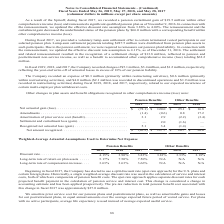From Conagra Brands's financial document, How much were the charges of the year-end write-off of actuarial losses during fiscal 2017, 2018, and 2019, respectively? The document contains multiple relevant values: $1.2 million, $3.4 million, $5.1 million. From the document: "017, the Company recorded charges of $5.1 million, $3.4 million, and $1.2 million, respectively, ecorded charges of $5.1 million, $3.4 million, and $1..." Also, What is the breakdown of $4.0 million expense during fiscal 2017 that was related to expected incurrence of certain multi-employer plan withdrawal costs? $2.1 million was recorded in discontinued operations and $1.9 million was recorded in restructuring activities. The document states: "thin restructuring activities), and $4.0 million ($2.1 million was recorded in discontinued operations and $1.9 million was recorded in restructuring ..." Also, What is the net amount recognized  for pension benefit during the fiscal year 2018 and 2019, respectively? The document shows two values: $127.7 and (65.3) (in millions). From the document: "Net amount recognized. . $ (65.3) $ 127.7 $ 20.7 $ 30.6 Net amount recognized. . $ (65.3) $ 127.7 $ 20.7 $ 30.6..." Also, can you calculate: What is the average amount of amendments for all benefits for fiscal 2018 and 2019? To answer this question, I need to perform calculations using the financial data. The calculation is: (-1.4+(-0.6)+0.8+17.2)/4 , which equals 4 (in millions). This is based on the information: "Amendments . (1.4) (0.6) 0.8 17.2 Amendments . (1.4) (0.6) 0.8 17.2 Amendments . (1.4) (0.6) 0.8 17.2 Amendments . (1.4) (0.6) 0.8 17.2..." The key data points involved are: 0.6, 0.8, 1.4. Also, can you calculate: What is the percentage change in the net amount recognized for other benefits from 2018 to 2019? To answer this question, I need to perform calculations using the financial data. The calculation is: (20.7-30.6)/30.6 , which equals -32.35 (percentage). This is based on the information: "Net amount recognized. . $ (65.3) $ 127.7 $ 20.7 $ 30.6 et amount recognized. . $ (65.3) $ 127.7 $ 20.7 $ 30.6..." The key data points involved are: 20.7, 30.6. Also, can you calculate: What is the percentage change in amortization of prior service cost for pension benefits in 2019 compared to 2018? To answer this question, I need to perform calculations using the financial data. The calculation is: (3.1-2.9)/2.9 , which equals 6.9 (percentage). This is based on the information: "Amortization of prior service cost (benefit). . 3.1 2.9 (2.2) (3.4) ortization of prior service cost (benefit). . 3.1 2.9 (2.2) (3.4)..." The key data points involved are: 2.9, 3.1. 